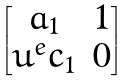Convert formula to latex. <formula><loc_0><loc_0><loc_500><loc_500>\begin{bmatrix} a _ { 1 } & 1 \\ u ^ { e } c _ { 1 } & 0 \end{bmatrix}</formula> 